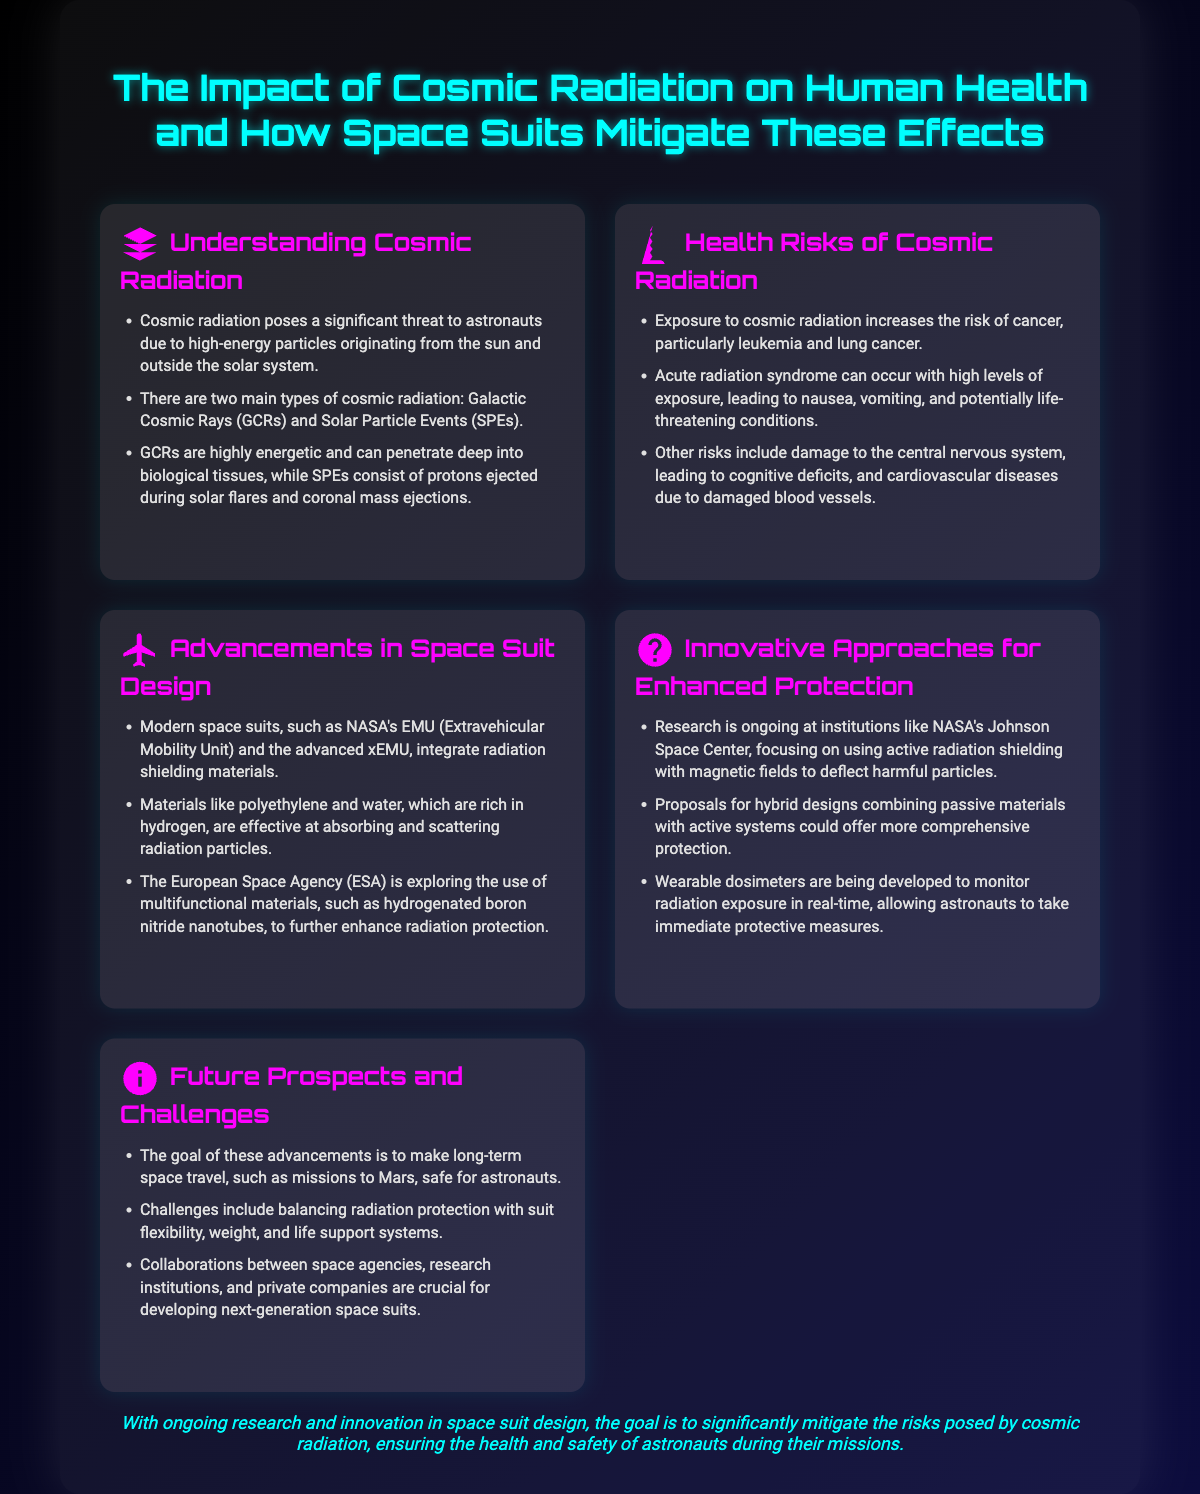What are the two main types of cosmic radiation? The document specifies that there are two main types of cosmic radiation: Galactic Cosmic Rays (GCRs) and Solar Particle Events (SPEs).
Answer: GCRs and SPEs What health risk is associated with cosmic radiation? The document lists exposure to cosmic radiation increases the risk of cancer, particularly leukemia and lung cancer.
Answer: Cancer What material is mentioned as effective in radiation shielding? The poster states that materials like polyethylene and water, which are rich in hydrogen, are effective at absorbing and scattering radiation particles.
Answer: Polyethylene and water Which institution is researching active radiation shielding? The document mentions that research is ongoing at institutions like NASA's Johnson Space Center, focusing on using active radiation shielding.
Answer: NASA's Johnson Space Center What is the goal of advancements in space suit design? The conclusion emphasizes that ongoing research aims to significantly mitigate the risks posed by cosmic radiation, ensuring the health and safety of astronauts during their missions.
Answer: Mitigate risks 